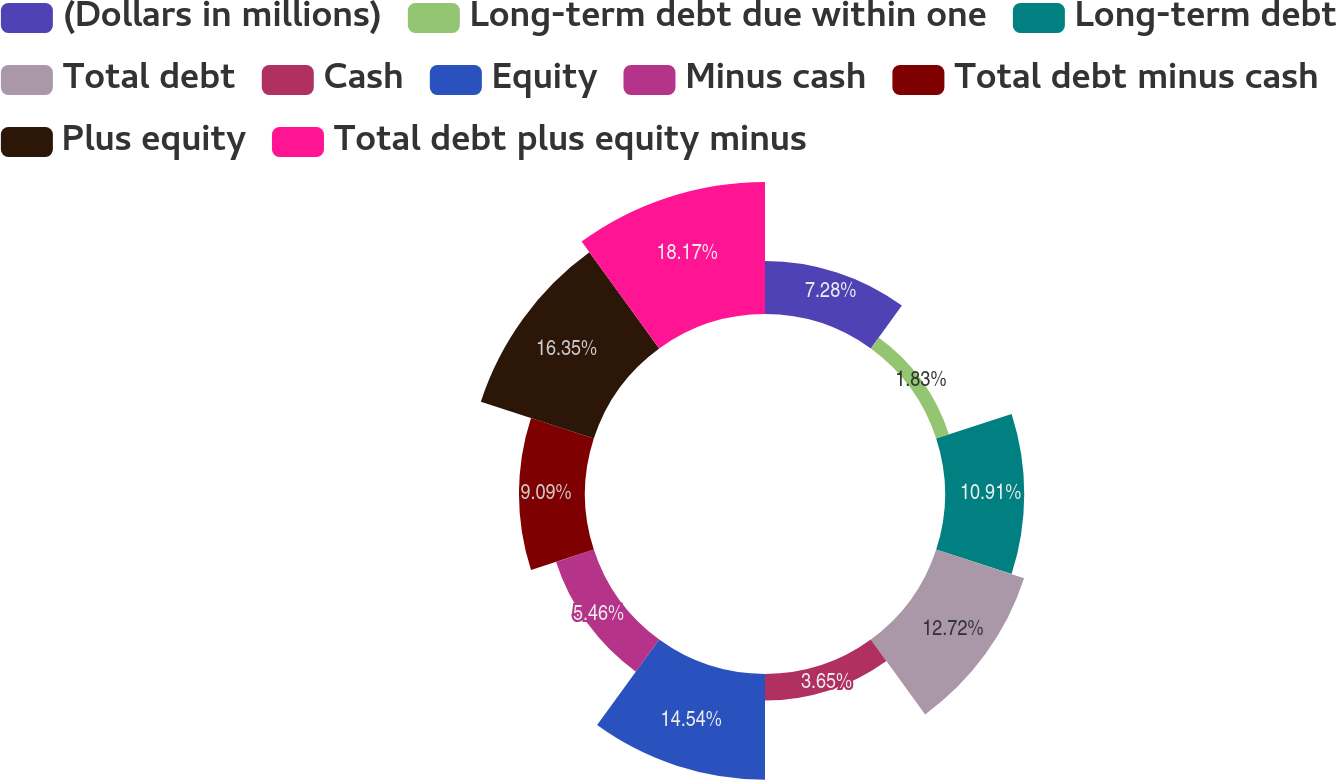Convert chart to OTSL. <chart><loc_0><loc_0><loc_500><loc_500><pie_chart><fcel>(Dollars in millions)<fcel>Long-term debt due within one<fcel>Long-term debt<fcel>Total debt<fcel>Cash<fcel>Equity<fcel>Minus cash<fcel>Total debt minus cash<fcel>Plus equity<fcel>Total debt plus equity minus<nl><fcel>7.28%<fcel>1.83%<fcel>10.91%<fcel>12.72%<fcel>3.65%<fcel>14.54%<fcel>5.46%<fcel>9.09%<fcel>16.35%<fcel>18.17%<nl></chart> 